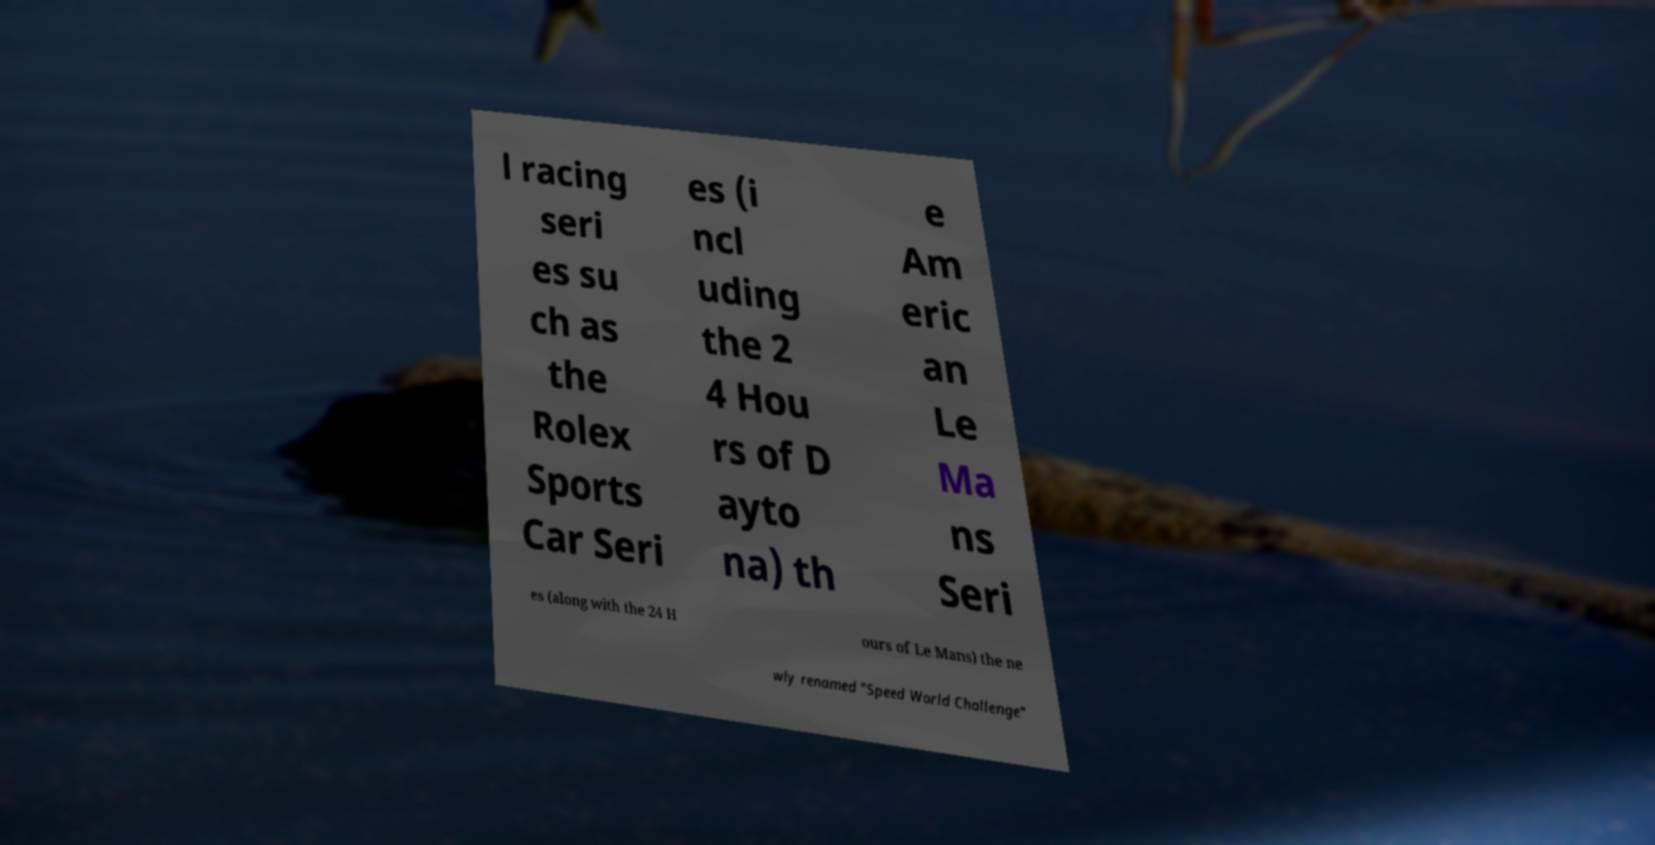Can you read and provide the text displayed in the image?This photo seems to have some interesting text. Can you extract and type it out for me? l racing seri es su ch as the Rolex Sports Car Seri es (i ncl uding the 2 4 Hou rs of D ayto na) th e Am eric an Le Ma ns Seri es (along with the 24 H ours of Le Mans) the ne wly renamed "Speed World Challenge" 